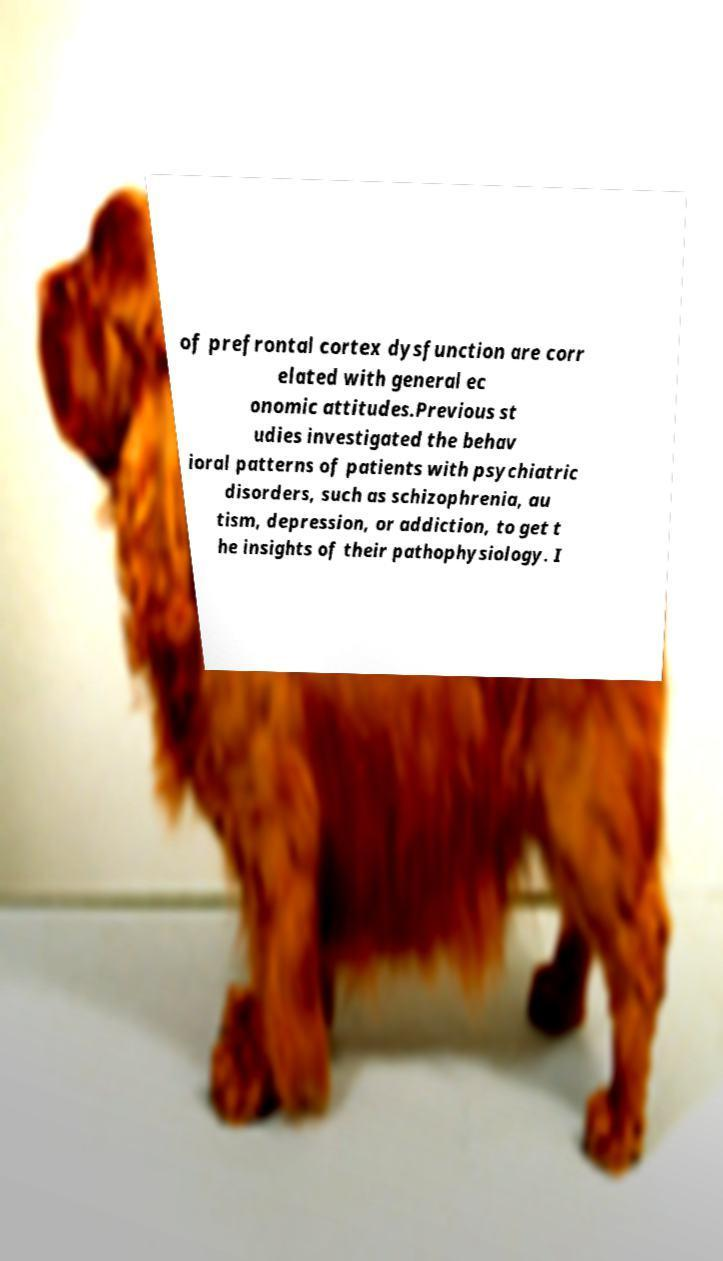Could you assist in decoding the text presented in this image and type it out clearly? of prefrontal cortex dysfunction are corr elated with general ec onomic attitudes.Previous st udies investigated the behav ioral patterns of patients with psychiatric disorders, such as schizophrenia, au tism, depression, or addiction, to get t he insights of their pathophysiology. I 